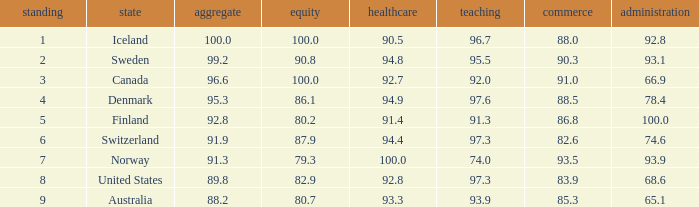What's the rank for iceland 1.0. 